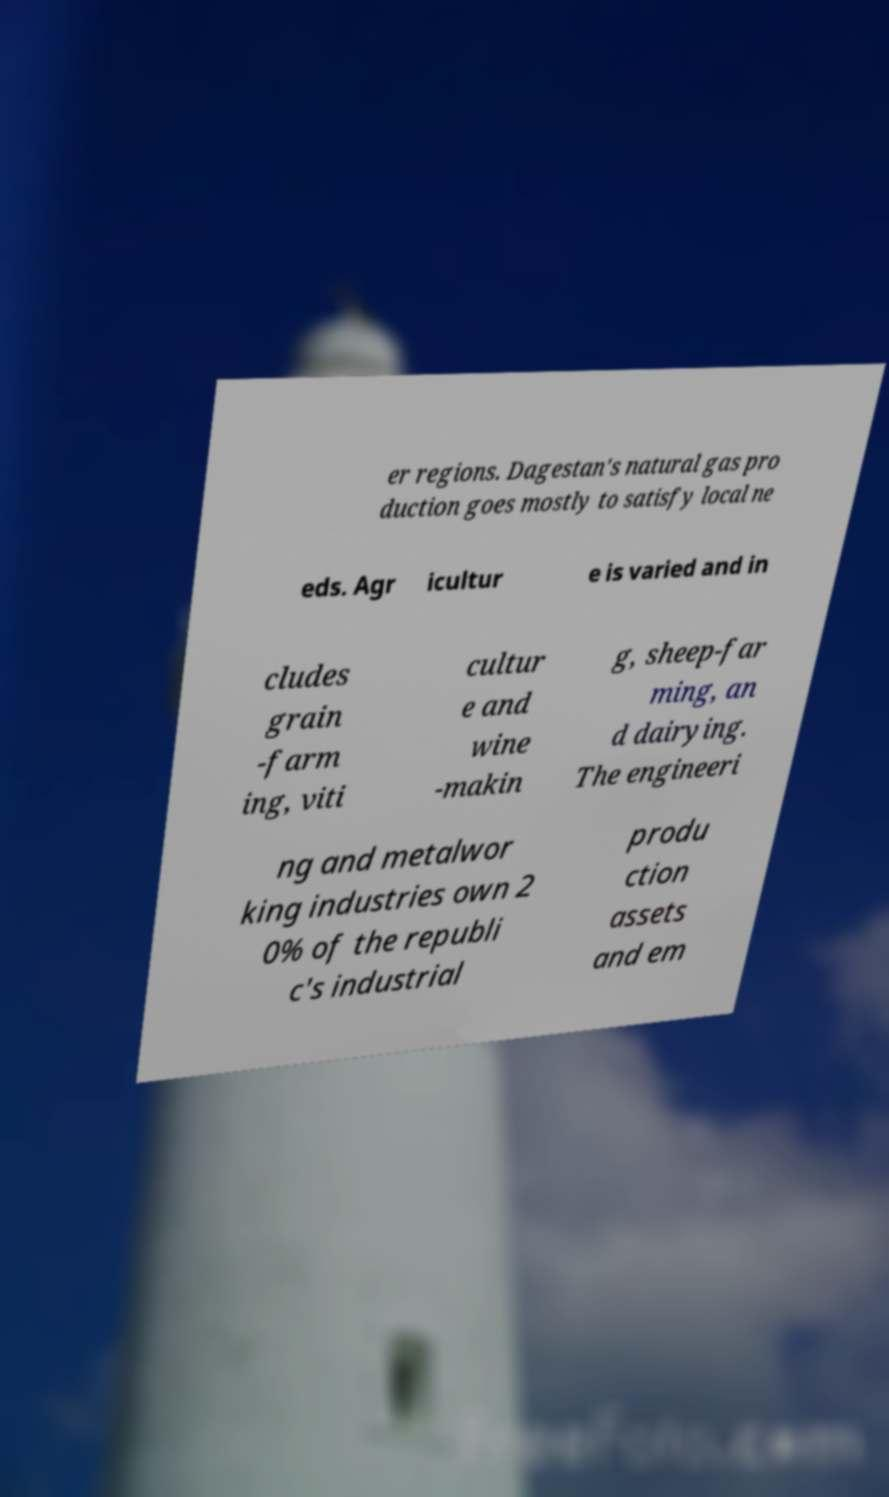Please read and relay the text visible in this image. What does it say? er regions. Dagestan's natural gas pro duction goes mostly to satisfy local ne eds. Agr icultur e is varied and in cludes grain -farm ing, viti cultur e and wine -makin g, sheep-far ming, an d dairying. The engineeri ng and metalwor king industries own 2 0% of the republi c's industrial produ ction assets and em 